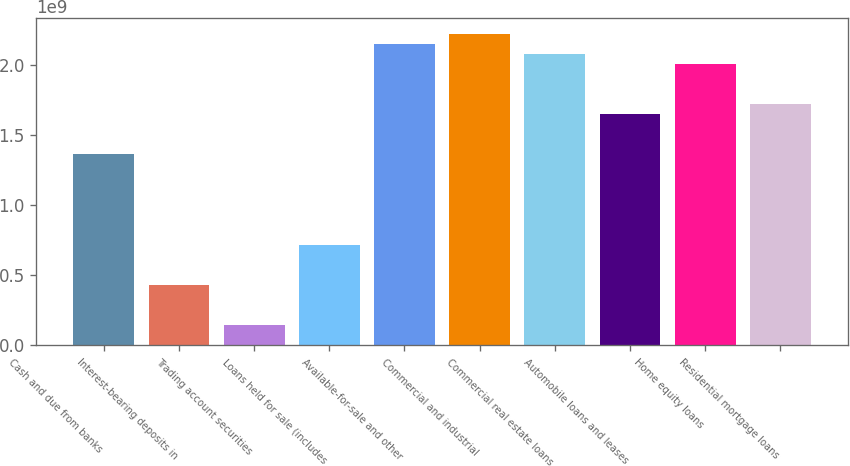<chart> <loc_0><loc_0><loc_500><loc_500><bar_chart><fcel>Cash and due from banks<fcel>Interest-bearing deposits in<fcel>Trading account securities<fcel>Loans held for sale (includes<fcel>Available-for-sale and other<fcel>Commercial and industrial<fcel>Commercial real estate loans<fcel>Automobile loans and leases<fcel>Home equity loans<fcel>Residential mortgage loans<nl><fcel>1.3618e+09<fcel>4.30048e+08<fcel>1.43354e+08<fcel>7.16741e+08<fcel>2.15021e+09<fcel>2.22188e+09<fcel>2.07854e+09<fcel>1.6485e+09<fcel>2.00686e+09<fcel>1.72017e+09<nl></chart> 